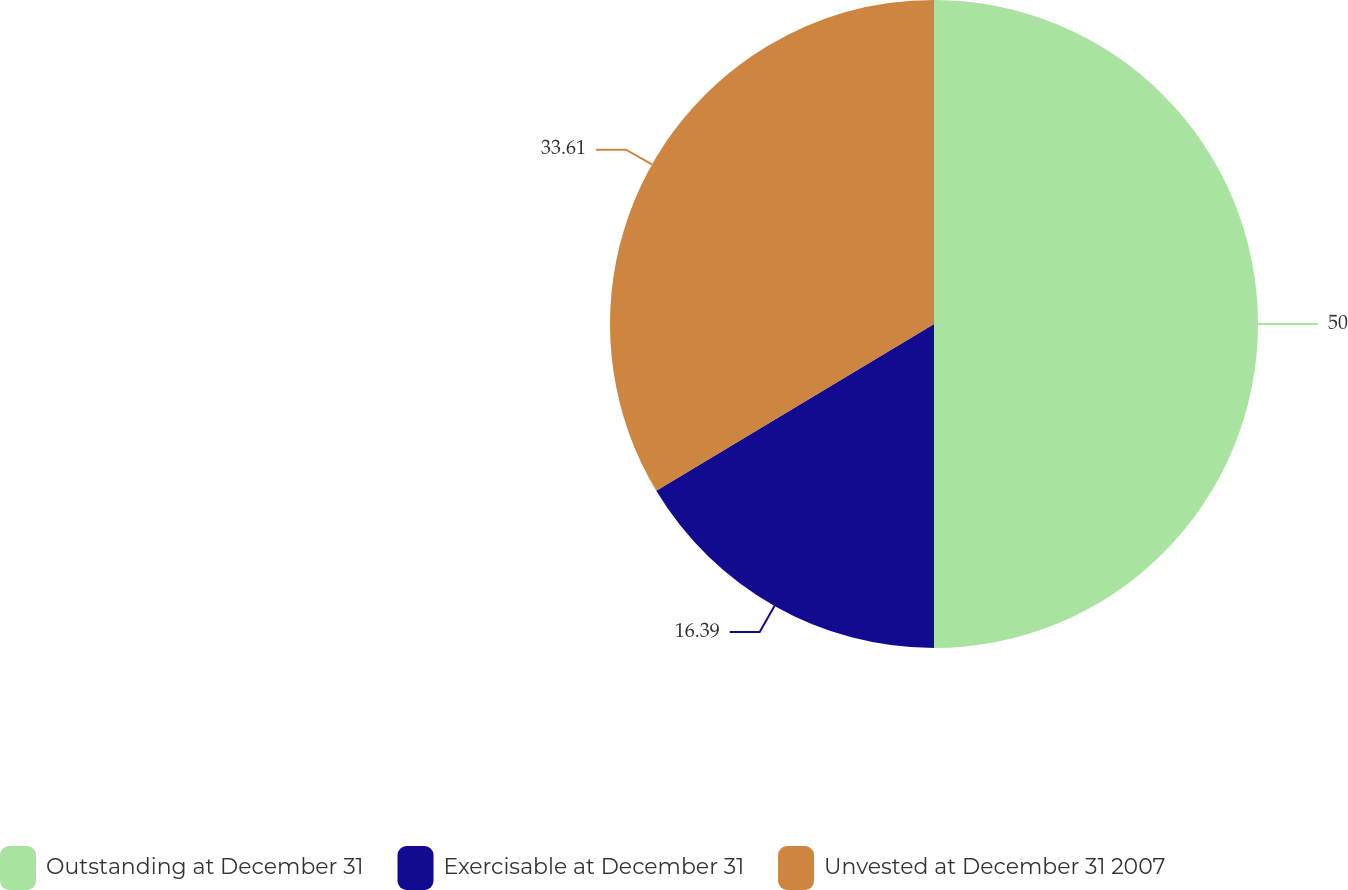Convert chart. <chart><loc_0><loc_0><loc_500><loc_500><pie_chart><fcel>Outstanding at December 31<fcel>Exercisable at December 31<fcel>Unvested at December 31 2007<nl><fcel>50.0%<fcel>16.39%<fcel>33.61%<nl></chart> 